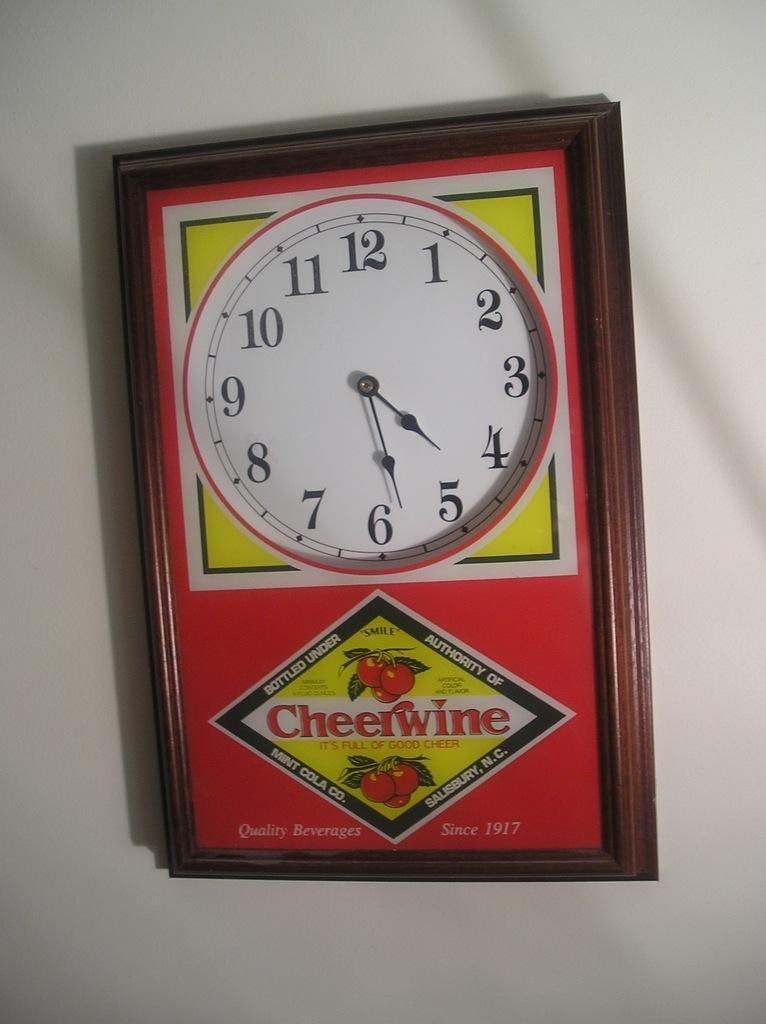<image>
Offer a succinct explanation of the picture presented. The clock is yellow and red and is from Cheerwine. 